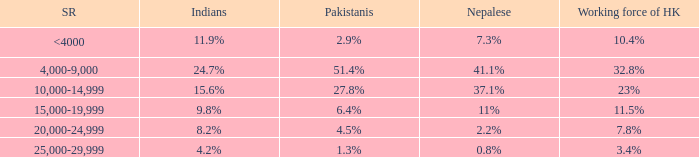If the working force of HK is 10.4%, what is the salary range? <4000. 